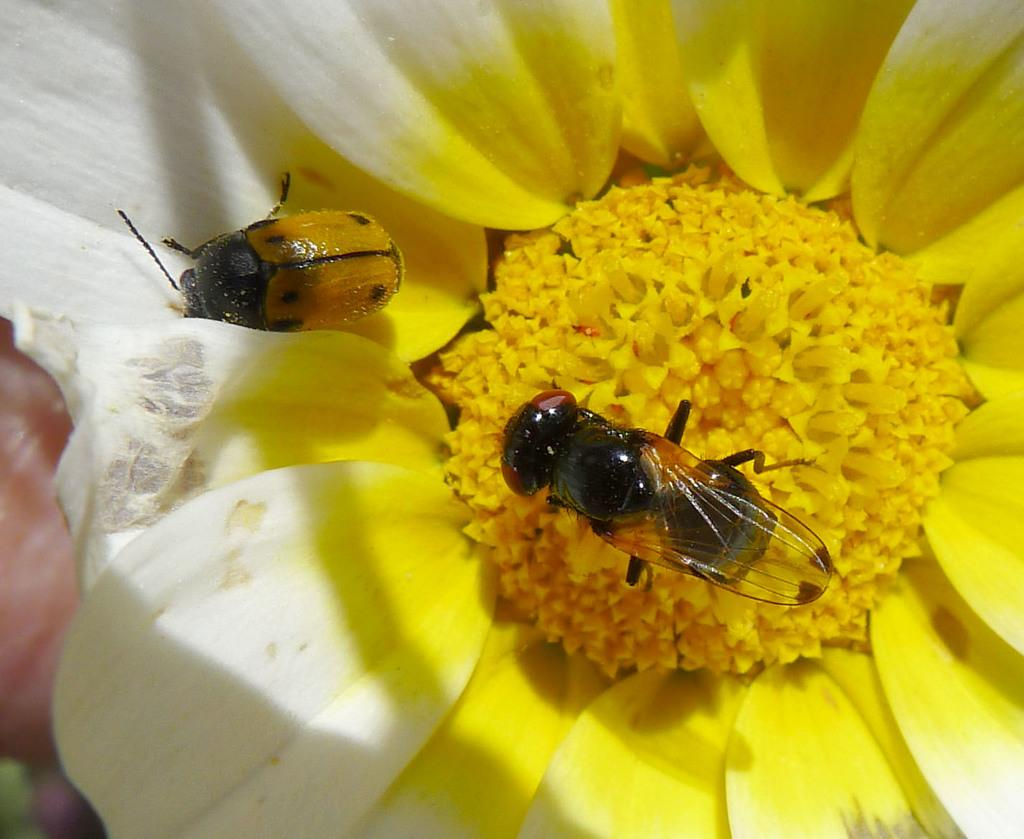What is the main subject of the image? There is a flower in the image. Are there any other living organisms present on the flower? Yes, insects are present on the flower. What type of tank can be seen in the image? There is no tank present in the image; it features a flower with insects on it. How does the flower stretch in the image? The flower does not stretch in the image; it is stationary. 